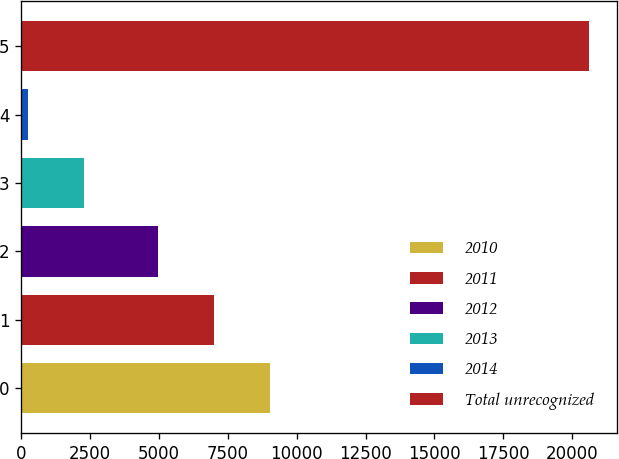<chart> <loc_0><loc_0><loc_500><loc_500><bar_chart><fcel>2010<fcel>2011<fcel>2012<fcel>2013<fcel>2014<fcel>Total unrecognized<nl><fcel>9040.6<fcel>7004.8<fcel>4969<fcel>2282.8<fcel>247<fcel>20605<nl></chart> 